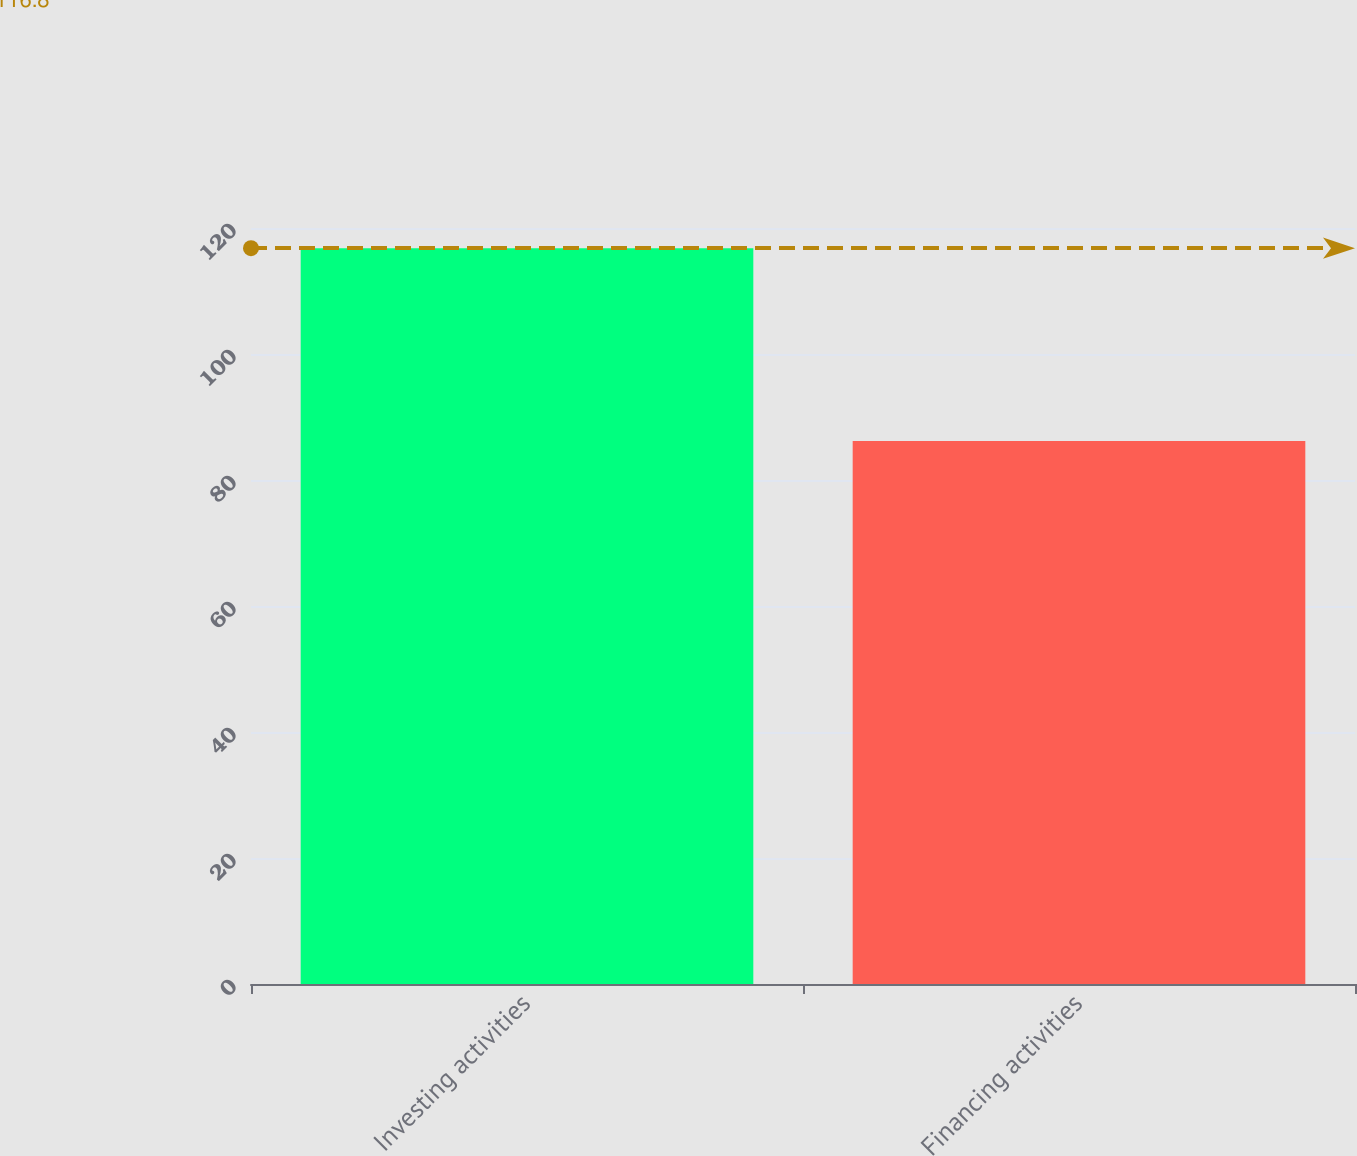<chart> <loc_0><loc_0><loc_500><loc_500><bar_chart><fcel>Investing activities<fcel>Financing activities<nl><fcel>116.8<fcel>86.2<nl></chart> 